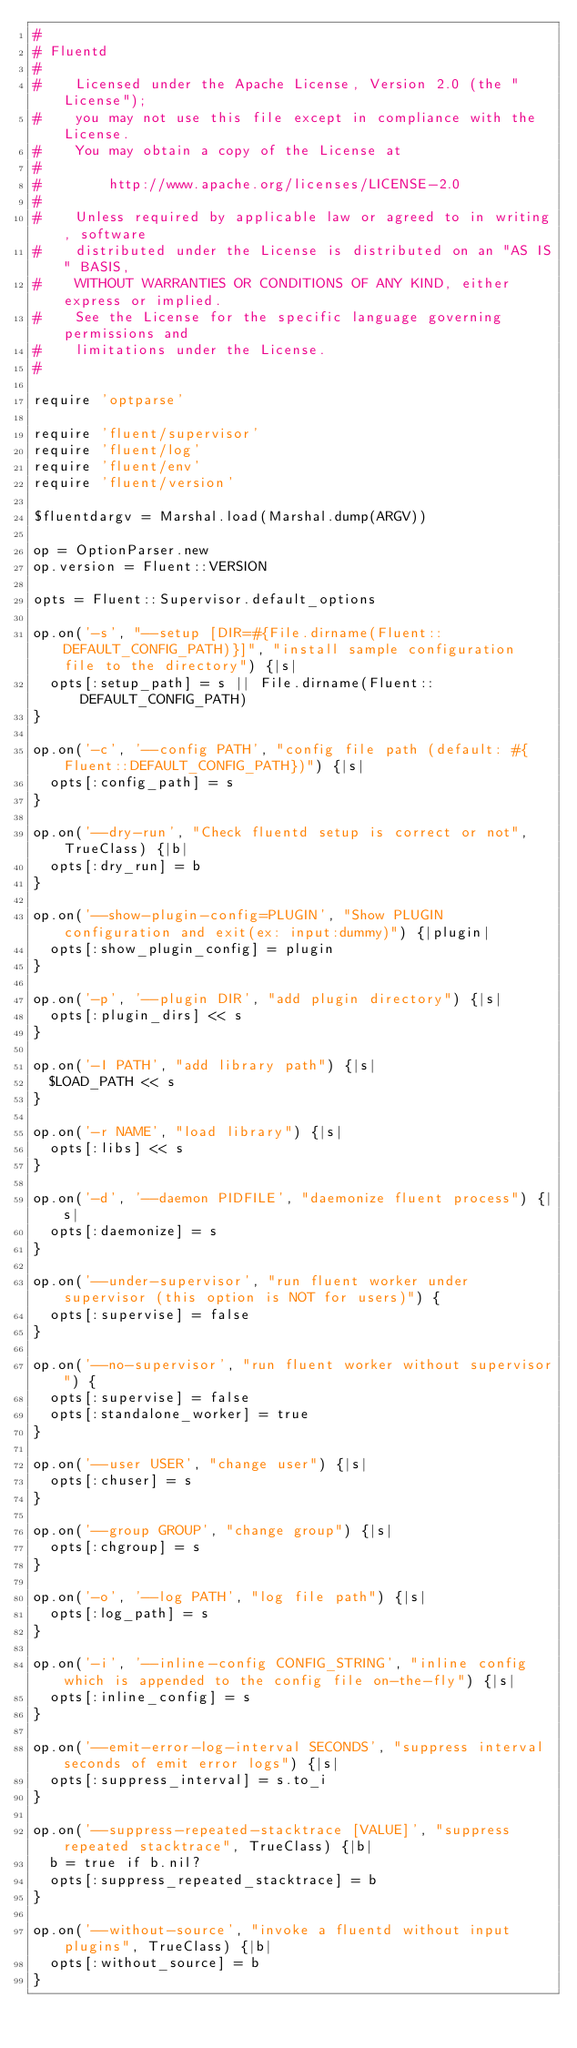Convert code to text. <code><loc_0><loc_0><loc_500><loc_500><_Ruby_>#
# Fluentd
#
#    Licensed under the Apache License, Version 2.0 (the "License");
#    you may not use this file except in compliance with the License.
#    You may obtain a copy of the License at
#
#        http://www.apache.org/licenses/LICENSE-2.0
#
#    Unless required by applicable law or agreed to in writing, software
#    distributed under the License is distributed on an "AS IS" BASIS,
#    WITHOUT WARRANTIES OR CONDITIONS OF ANY KIND, either express or implied.
#    See the License for the specific language governing permissions and
#    limitations under the License.
#

require 'optparse'

require 'fluent/supervisor'
require 'fluent/log'
require 'fluent/env'
require 'fluent/version'

$fluentdargv = Marshal.load(Marshal.dump(ARGV))

op = OptionParser.new
op.version = Fluent::VERSION

opts = Fluent::Supervisor.default_options

op.on('-s', "--setup [DIR=#{File.dirname(Fluent::DEFAULT_CONFIG_PATH)}]", "install sample configuration file to the directory") {|s|
  opts[:setup_path] = s || File.dirname(Fluent::DEFAULT_CONFIG_PATH)
}

op.on('-c', '--config PATH', "config file path (default: #{Fluent::DEFAULT_CONFIG_PATH})") {|s|
  opts[:config_path] = s
}

op.on('--dry-run', "Check fluentd setup is correct or not", TrueClass) {|b|
  opts[:dry_run] = b
}

op.on('--show-plugin-config=PLUGIN', "Show PLUGIN configuration and exit(ex: input:dummy)") {|plugin|
  opts[:show_plugin_config] = plugin
}

op.on('-p', '--plugin DIR', "add plugin directory") {|s|
  opts[:plugin_dirs] << s
}

op.on('-I PATH', "add library path") {|s|
  $LOAD_PATH << s
}

op.on('-r NAME', "load library") {|s|
  opts[:libs] << s
}

op.on('-d', '--daemon PIDFILE', "daemonize fluent process") {|s|
  opts[:daemonize] = s
}

op.on('--under-supervisor', "run fluent worker under supervisor (this option is NOT for users)") {
  opts[:supervise] = false
}

op.on('--no-supervisor', "run fluent worker without supervisor") {
  opts[:supervise] = false
  opts[:standalone_worker] = true
}

op.on('--user USER', "change user") {|s|
  opts[:chuser] = s
}

op.on('--group GROUP', "change group") {|s|
  opts[:chgroup] = s
}

op.on('-o', '--log PATH', "log file path") {|s|
  opts[:log_path] = s
}

op.on('-i', '--inline-config CONFIG_STRING', "inline config which is appended to the config file on-the-fly") {|s|
  opts[:inline_config] = s
}

op.on('--emit-error-log-interval SECONDS', "suppress interval seconds of emit error logs") {|s|
  opts[:suppress_interval] = s.to_i
}

op.on('--suppress-repeated-stacktrace [VALUE]', "suppress repeated stacktrace", TrueClass) {|b|
  b = true if b.nil?
  opts[:suppress_repeated_stacktrace] = b
}

op.on('--without-source', "invoke a fluentd without input plugins", TrueClass) {|b|
  opts[:without_source] = b
}
</code> 